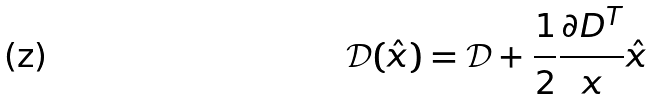<formula> <loc_0><loc_0><loc_500><loc_500>\mathcal { D } ( \hat { x } ) = \mathcal { D } + \frac { 1 } { 2 } \frac { \partial { D ^ { T } } } { x } \hat { x }</formula> 